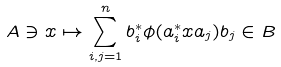<formula> <loc_0><loc_0><loc_500><loc_500>A \ni x \mapsto \sum _ { i , j = 1 } ^ { n } b _ { i } ^ { \ast } \phi ( a _ { i } ^ { \ast } x a _ { j } ) b _ { j } \in B</formula> 